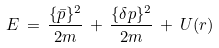<formula> <loc_0><loc_0><loc_500><loc_500>E \, = \, \frac { \{ \bar { p } \} ^ { 2 } } { 2 m } \, + \, \frac { \{ \delta p \} ^ { 2 } } { 2 m } \, + \, U ( r ) \,</formula> 